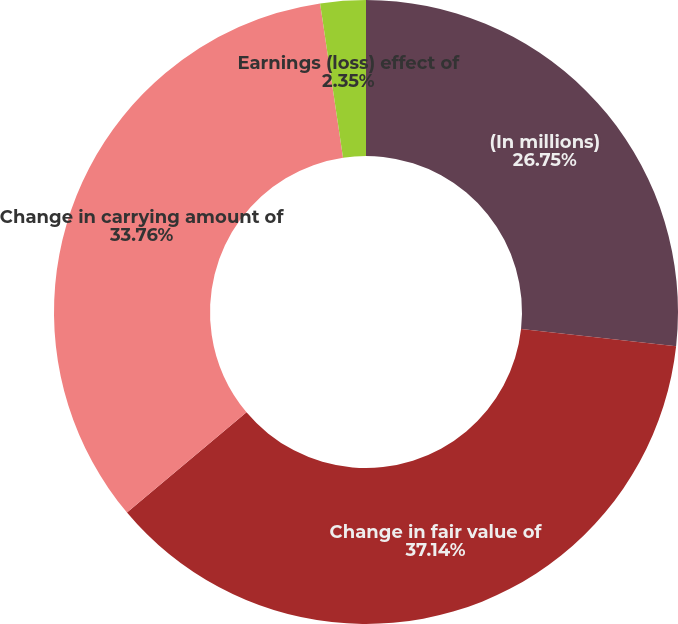Convert chart. <chart><loc_0><loc_0><loc_500><loc_500><pie_chart><fcel>(In millions)<fcel>Change in fair value of<fcel>Change in carrying amount of<fcel>Earnings (loss) effect of<nl><fcel>26.75%<fcel>37.14%<fcel>33.76%<fcel>2.35%<nl></chart> 